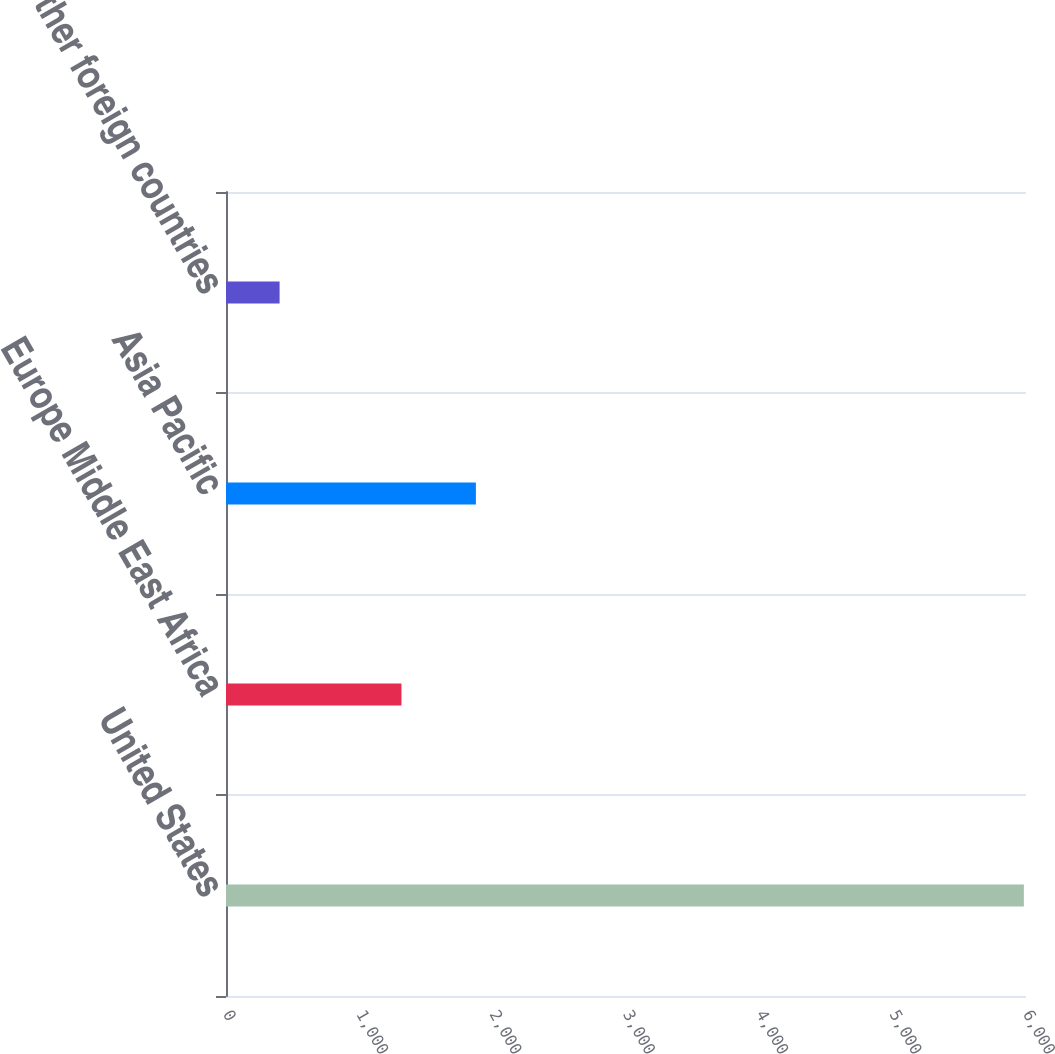<chart> <loc_0><loc_0><loc_500><loc_500><bar_chart><fcel>United States<fcel>Europe Middle East Africa<fcel>Asia Pacific<fcel>Other foreign countries<nl><fcel>5984<fcel>1316<fcel>1874.2<fcel>402<nl></chart> 